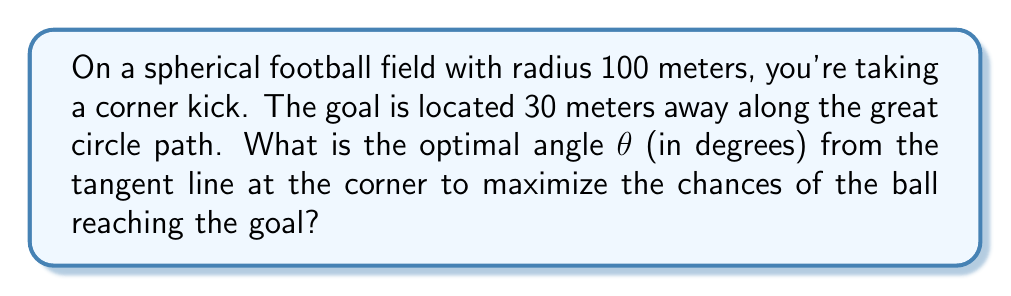Solve this math problem. Let's approach this step-by-step:

1) On a spherical surface, the shortest path between two points is along a great circle. The optimal kick would follow this path.

2) We can use spherical trigonometry to solve this problem. The relevant formula is the spherical law of sines:

   $$\frac{\sin A}{\sin a} = \frac{\sin B}{\sin b} = \frac{\sin C}{\sin c}$$

   where $A$, $B$, and $C$ are angles, and $a$, $b$, and $c$ are the lengths of the sides opposite to these angles (measured as central angles from the center of the sphere).

3) In our case, we have a right-angled spherical triangle where:
   - $c$ is the central angle corresponding to the 30-meter arc length
   - $A$ is the right angle (90°)
   - $B$ is the angle we're looking for ($\theta$)

4) We need to find the central angle $c$. The arc length formula is:

   $$s = r\theta$$

   where $s$ is the arc length, $r$ is the radius, and $\theta$ is the central angle in radians.

5) Rearranging and converting to degrees:

   $$c = \frac{s}{r} \cdot \frac{180°}{\pi} = \frac{30}{100} \cdot \frac{180°}{\pi} \approx 17.19°$$

6) Now we can use the spherical law of sines:

   $$\frac{\sin 90°}{\sin c} = \frac{\sin \theta}{\sin 90°}$$

7) Simplifying:

   $$\frac{1}{\sin c} = \sin \theta$$

8) Solving for $\theta$:

   $$\theta = \arcsin(\frac{1}{\sin c})$$

9) Plugging in our value for $c$:

   $$\theta = \arcsin(\frac{1}{\sin 17.19°}) \approx 80.44°$$

This angle is measured from the great circle path. To get the angle from the tangent line, we subtract from 90°:

$$90° - 80.44° = 9.56°$$
Answer: $9.56°$ 